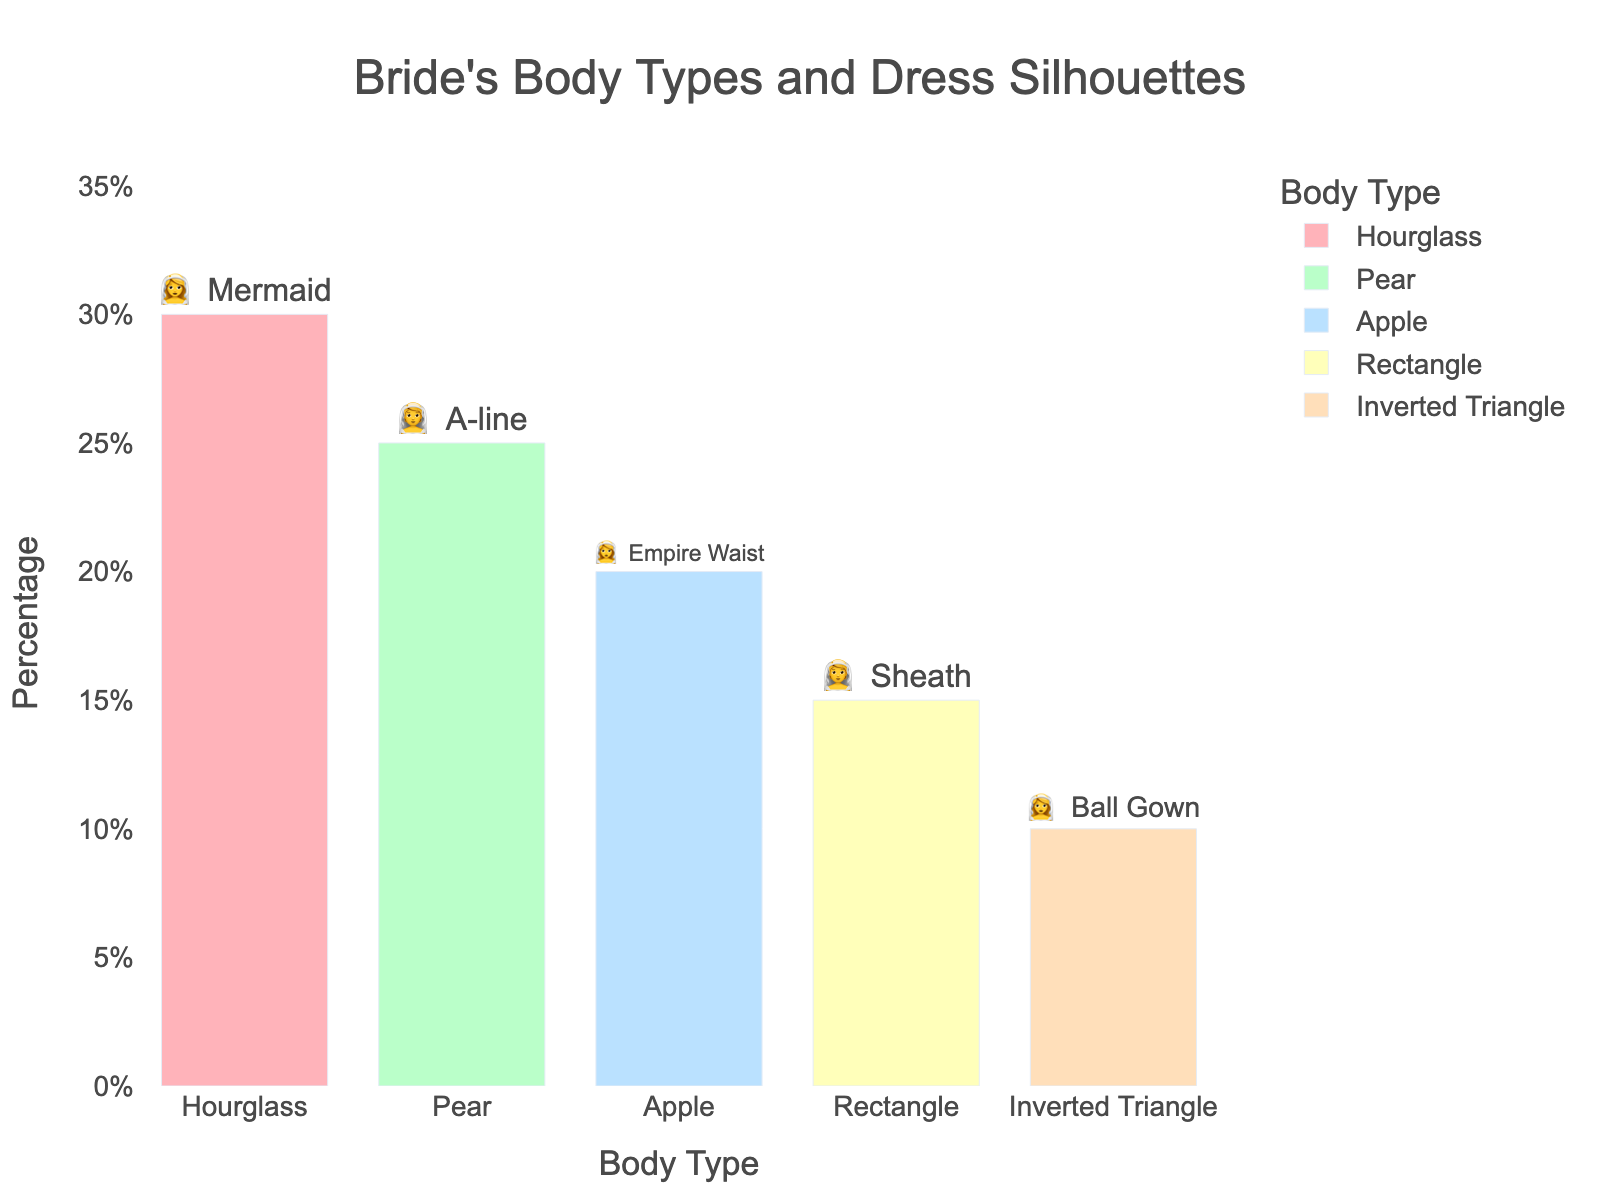What is the most common dress silhouette for a bride with an hourglass body type? The figure shows the body types and dress silhouettes as annotated emojis and text. For an hourglass body type, the text next to the emoji represents "Mermaid".
Answer: Mermaid What percentage of brides have a pear body type? Look at the bar labeled "Pear" and interpret the percentage above or next to it.
Answer: 25% Which body type has the least percentage of brides? The smallest bar corresponds to "Inverted Triangle" with a percentage of 10%.
Answer: Inverted Triangle What dress silhouette is associated with apple body type? Refer to the text next to the emoji for the bar labeled "Apple", which shows "Empire Waist".
Answer: Empire Waist How many body types account for more than 20% of the brides? Identify bars that exceed 20% on the y-axis. Hourglass (30%) and Pear (25%) both meet this criterion.
Answer: 2 If we combine the percentage of brides with an apple and rectangle body type, what is the total? Add the percentages for apple (20%) and rectangle (15%), which gives 35%.
Answer: 35% How does the percentage of brides with an inverted triangle body type compare with those having a rectangular body type? Compare the values: Inverted Triangle is 10%, Rectangle is 15%. So, Rectangle (15%) > Inverted Triangle (10%).
Answer: Rectangle > Inverted Triangle What is the dress silhouette for brides with a rectangular body type? For the rectangular body type, the text next to the emoji indicates "Sheath".
Answer: Sheath Which silhouette is most common overall among the brides depicted in the chart? Since hourglass body type has the highest percentage (30%) and is associated with the mermaid dress silhouette, mermaid is the most common overall.
Answer: Mermaid 